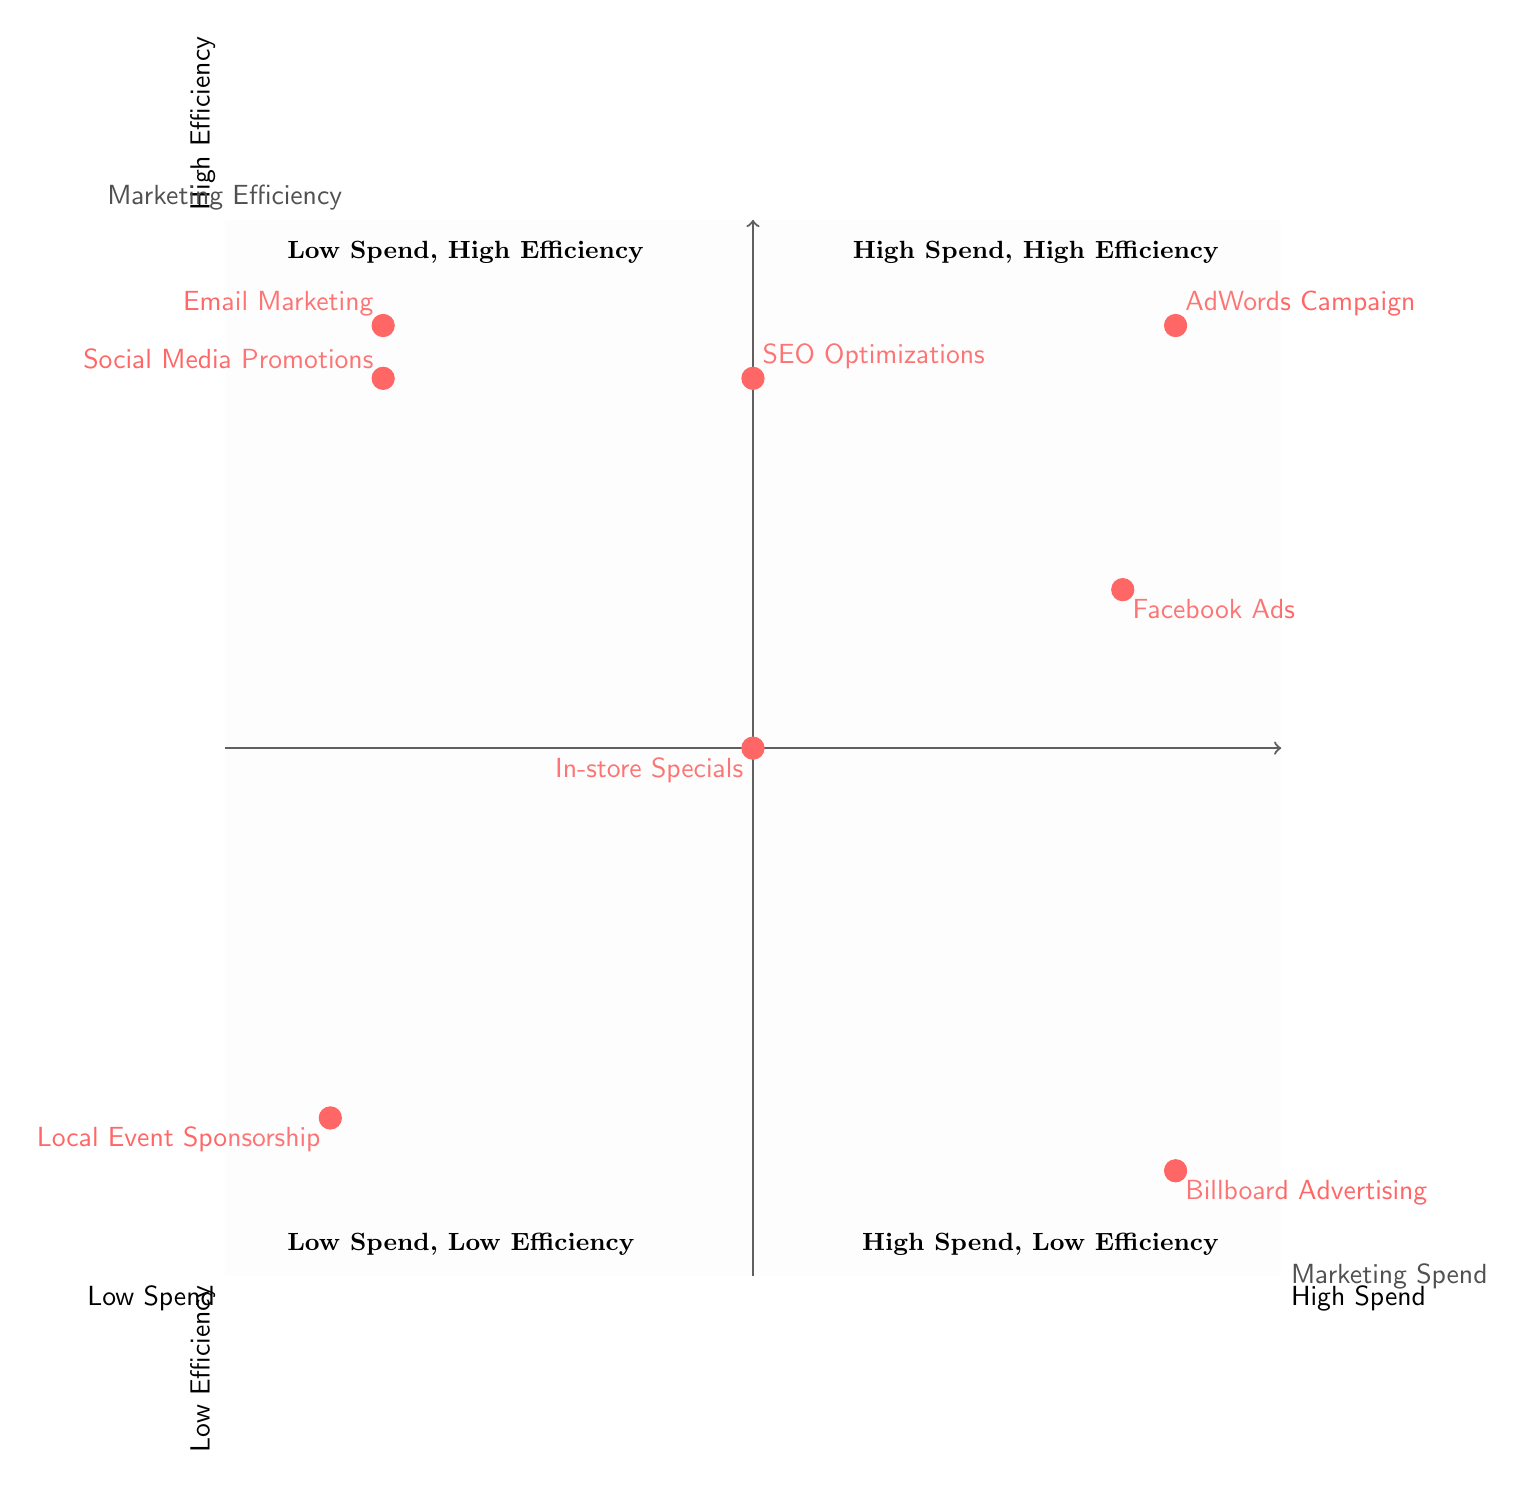What marketing strategy is placed in the High Spend, High Efficiency quadrant? The diagram indicates that the AdWords Campaign is located in the High Spend, High Efficiency quadrant, as it is positioned at (0.8, 0.8) in this area.
Answer: AdWords Campaign How many strategies fall into the Low Spend, High Efficiency quadrant? Upon reviewing the diagram, there are two strategies: Email Marketing and Social Media Promotions. These are identified as having Low Spend and High Efficiency.
Answer: 2 Which strategy has High Spend but Low Efficiency? The diagram shows that Billboard Advertising is the strategy with High Spend and Low Efficiency, positioned at (0.8, -0.8).
Answer: Billboard Advertising What is the efficiency level of Email Marketing? Email Marketing is placed at (-0.7, 0.8) on the diagram, indicating it has High Efficiency, as it is at a high point on the Y-axis.
Answer: High Efficiency Which quadrant contains strategies that are both Low Spend and Low Efficiency? The diagram indicates that the Low Spend and Low Efficiency quadrant consists of Local Event Sponsorship, which is positioned at (-0.8, -0.7).
Answer: Low Spend, Low Efficiency What is the placement of SEO Optimizations in terms of spend and efficiency? SEO Optimizations is located at (0, 0.7), which positions it in the Medium Spend and High Efficiency region of the diagram, showing a balanced placement.
Answer: Medium Spend, High Efficiency How many total strategies are represented in the quadrant chart? By counting the data points listed in the quadrants of the diagram, there are a total of eight marketing strategies shown.
Answer: 8 Which marketing activity is considered to have the highest efficiency with low spend? The strategy with the highest efficiency that also falls under low spend is both Email Marketing and Social Media Promotions; they both show high efficiency despite low spending.
Answer: Email Marketing, Social Media Promotions 